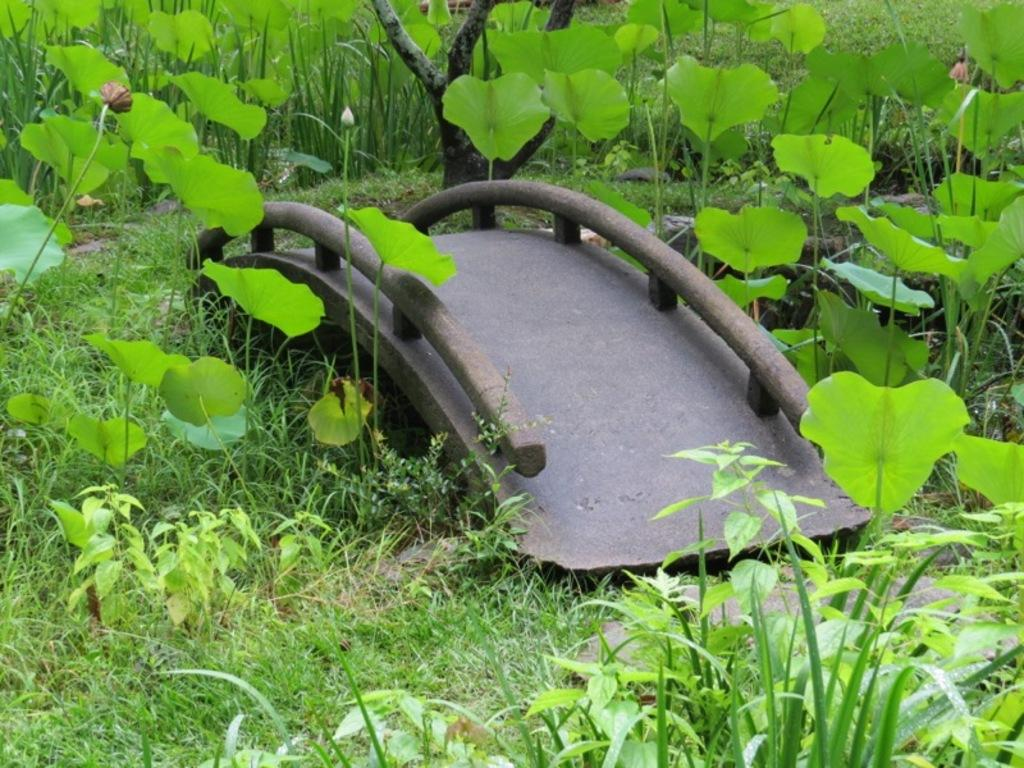What structure is present in the image? There is a bridge in the image. What type of vegetation can be seen in the image? There is grass and plants visible in the image. Can you describe the stage of growth of one of the plants in the image? There is a bud in the image, indicating that the plant is in the early stages of growth. What type of authority is depicted in the image? There is no authority figure present in the image; it features a bridge, grass, plants, and a bud. What type of shock can be seen in the image? There is no shock present in the image; it features a bridge, grass, plants, and a bud. 